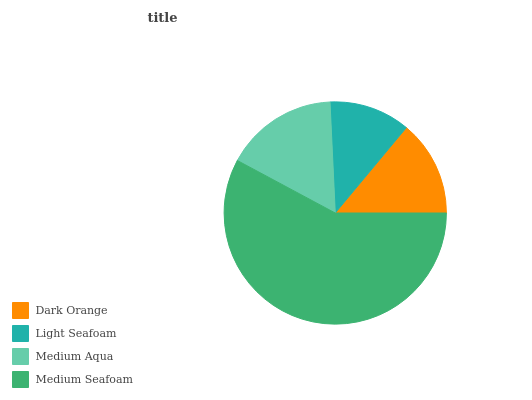Is Light Seafoam the minimum?
Answer yes or no. Yes. Is Medium Seafoam the maximum?
Answer yes or no. Yes. Is Medium Aqua the minimum?
Answer yes or no. No. Is Medium Aqua the maximum?
Answer yes or no. No. Is Medium Aqua greater than Light Seafoam?
Answer yes or no. Yes. Is Light Seafoam less than Medium Aqua?
Answer yes or no. Yes. Is Light Seafoam greater than Medium Aqua?
Answer yes or no. No. Is Medium Aqua less than Light Seafoam?
Answer yes or no. No. Is Medium Aqua the high median?
Answer yes or no. Yes. Is Dark Orange the low median?
Answer yes or no. Yes. Is Light Seafoam the high median?
Answer yes or no. No. Is Medium Aqua the low median?
Answer yes or no. No. 